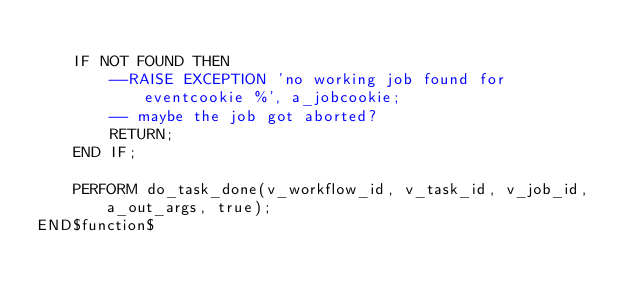Convert code to text. <code><loc_0><loc_0><loc_500><loc_500><_SQL_>
	IF NOT FOUND THEN
		--RAISE EXCEPTION 'no working job found for eventcookie %', a_jobcookie;
		-- maybe the job got aborted?
		RETURN;
	END IF;	

	PERFORM do_task_done(v_workflow_id, v_task_id, v_job_id, a_out_args, true);
END$function$
</code> 